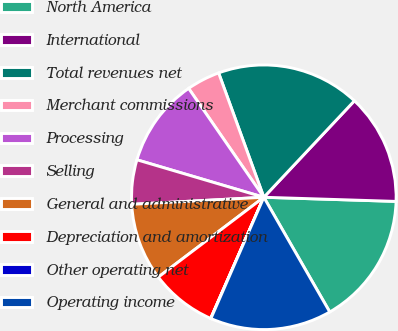Convert chart. <chart><loc_0><loc_0><loc_500><loc_500><pie_chart><fcel>North America<fcel>International<fcel>Total revenues net<fcel>Merchant commissions<fcel>Processing<fcel>Selling<fcel>General and administrative<fcel>Depreciation and amortization<fcel>Other operating net<fcel>Operating income<nl><fcel>16.2%<fcel>13.5%<fcel>17.55%<fcel>4.07%<fcel>10.81%<fcel>5.42%<fcel>9.46%<fcel>8.11%<fcel>0.03%<fcel>14.85%<nl></chart> 